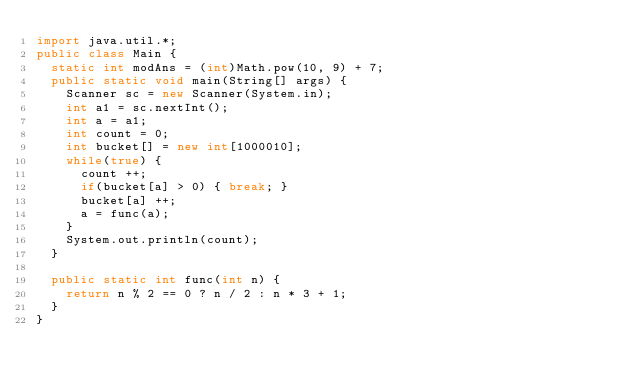Convert code to text. <code><loc_0><loc_0><loc_500><loc_500><_Java_>import java.util.*;
public class Main {
	static int modAns = (int)Math.pow(10, 9) + 7;
	public static void main(String[] args) {
		Scanner sc = new Scanner(System.in);
		int a1 = sc.nextInt();
		int a = a1;
		int count = 0;
		int bucket[] = new int[1000010];
		while(true) {
			count ++;
			if(bucket[a] > 0) { break; }
			bucket[a] ++;
			a = func(a);
		}
		System.out.println(count);
	}

	public static int func(int n) {
		return n % 2 == 0 ? n / 2 : n * 3 + 1;
	}
}</code> 